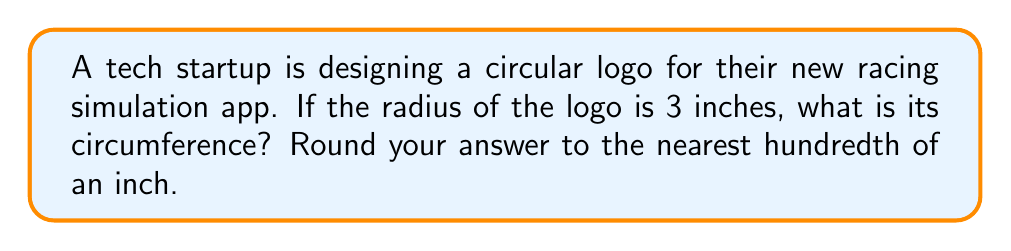What is the answer to this math problem? To solve this problem, we'll use the formula for the circumference of a circle:

$$C = 2\pi r$$

Where:
$C$ = circumference
$\pi$ = pi (approximately 3.14159)
$r$ = radius

Given:
$r = 3$ inches

Let's substitute these values into the formula:

$$C = 2\pi(3)$$

Now, let's calculate:

$$C = 6\pi$$

We can approximate this value by multiplying 6 by 3.14159:

$$C \approx 6 * 3.14159 = 18.84954$$

Rounding to the nearest hundredth:

$$C \approx 18.85\text{ inches}$$
Answer: $18.85\text{ inches}$ 